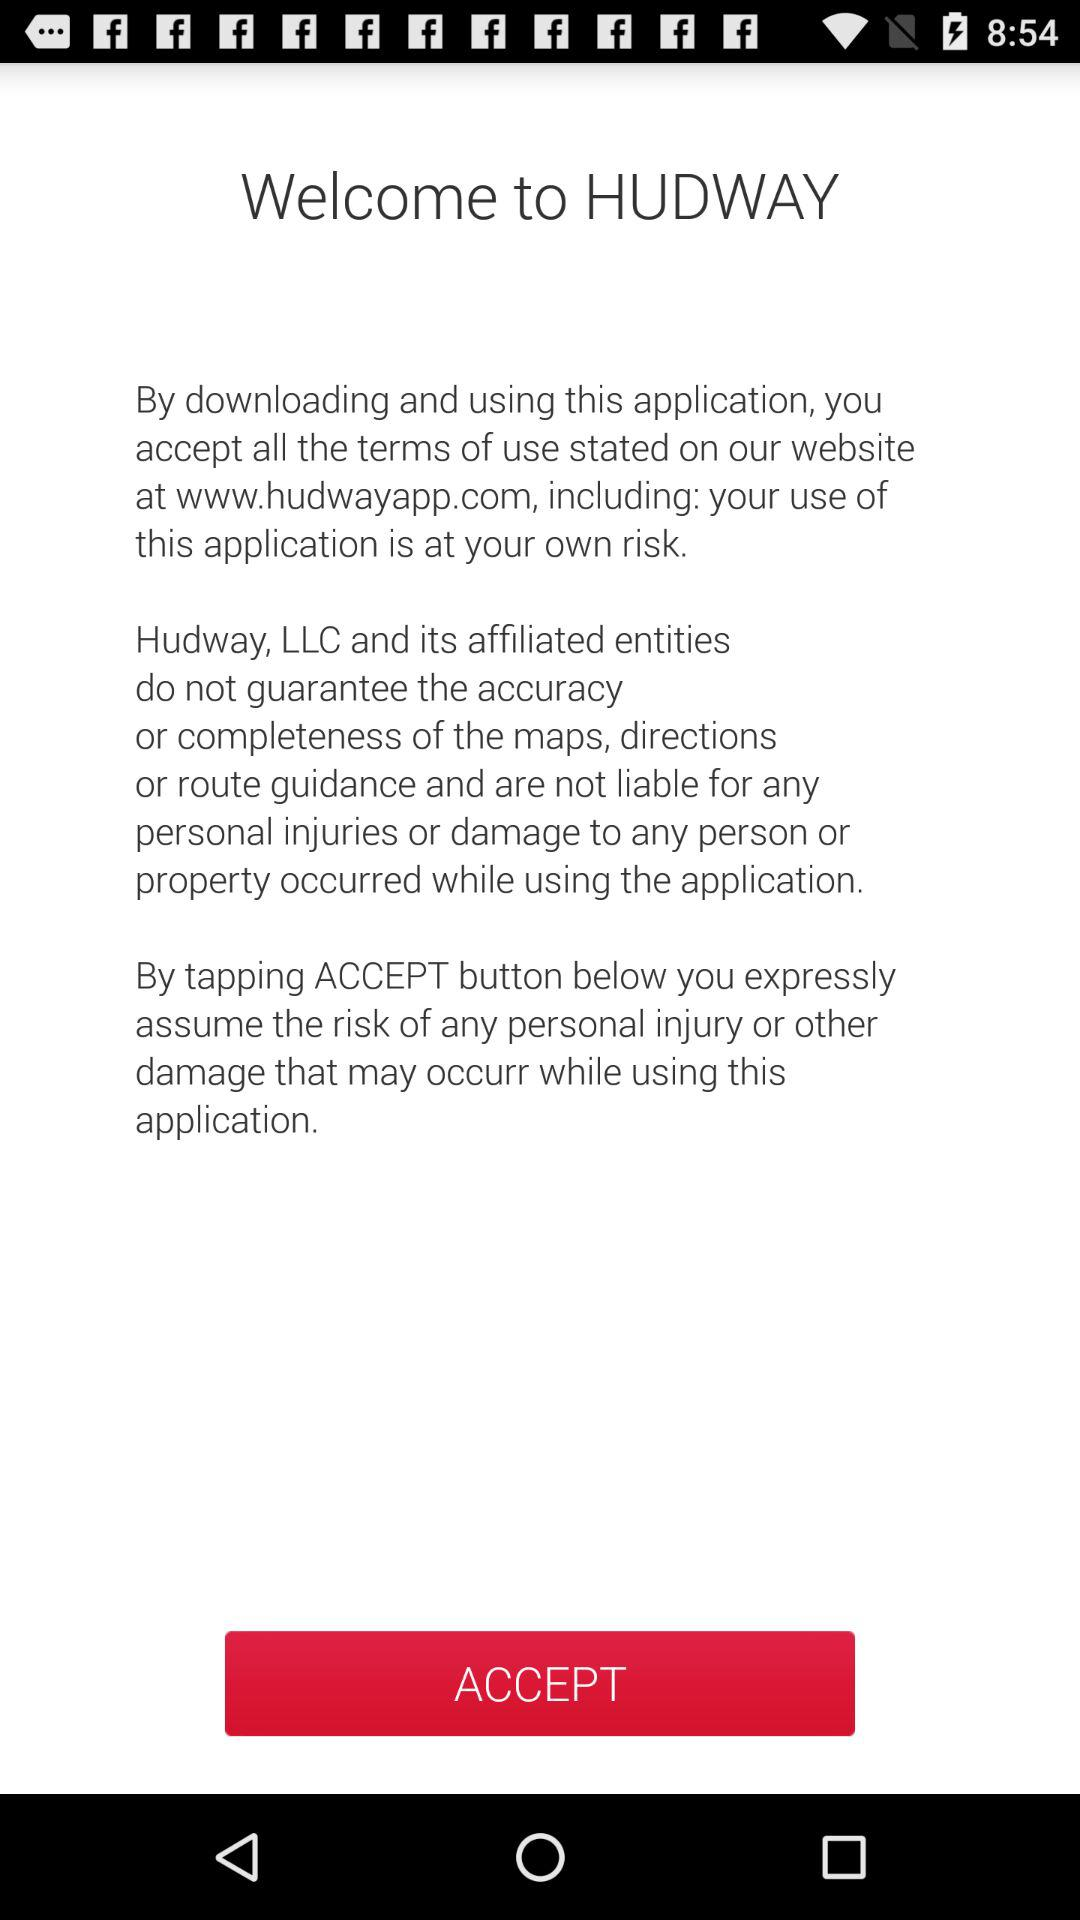What is the website? The website is www.hudwayapp.com. 